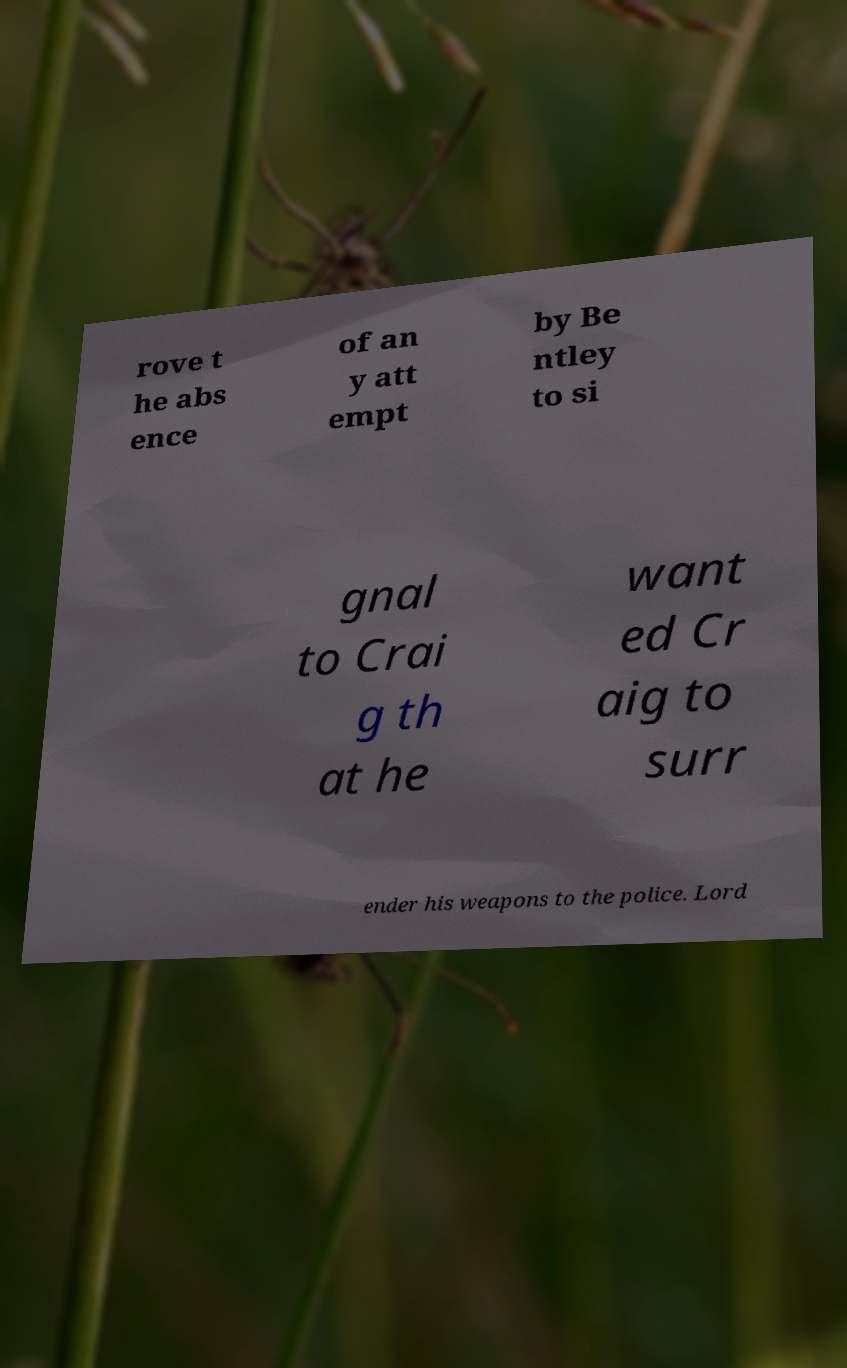Please read and relay the text visible in this image. What does it say? rove t he abs ence of an y att empt by Be ntley to si gnal to Crai g th at he want ed Cr aig to surr ender his weapons to the police. Lord 